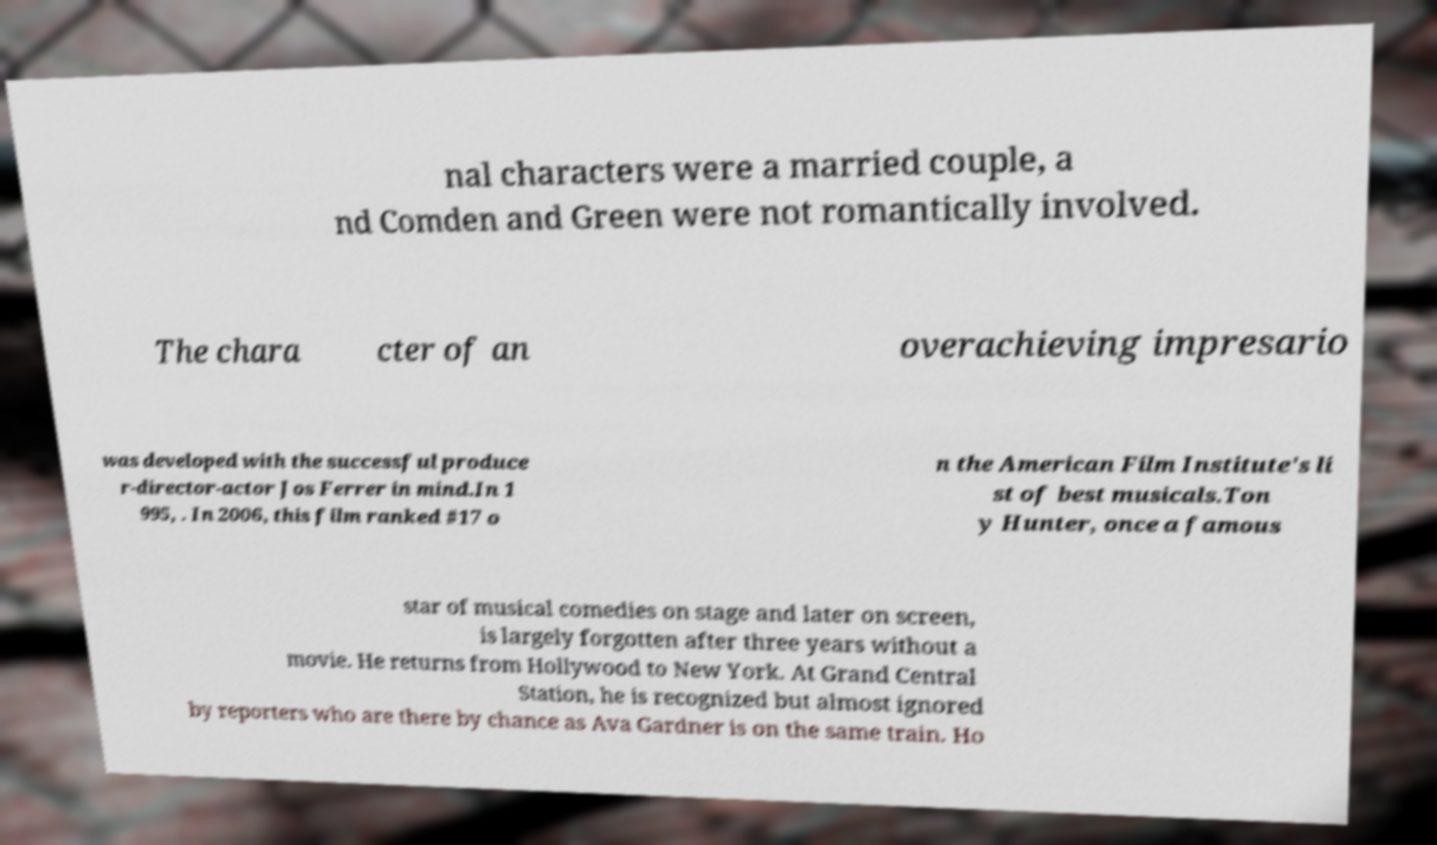For documentation purposes, I need the text within this image transcribed. Could you provide that? nal characters were a married couple, a nd Comden and Green were not romantically involved. The chara cter of an overachieving impresario was developed with the successful produce r-director-actor Jos Ferrer in mind.In 1 995, . In 2006, this film ranked #17 o n the American Film Institute's li st of best musicals.Ton y Hunter, once a famous star of musical comedies on stage and later on screen, is largely forgotten after three years without a movie. He returns from Hollywood to New York. At Grand Central Station, he is recognized but almost ignored by reporters who are there by chance as Ava Gardner is on the same train. Ho 